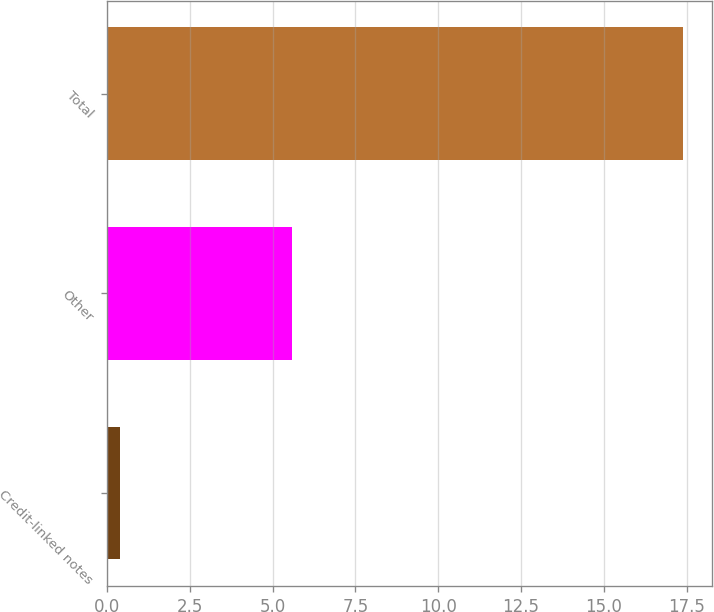Convert chart. <chart><loc_0><loc_0><loc_500><loc_500><bar_chart><fcel>Credit-linked notes<fcel>Other<fcel>Total<nl><fcel>0.4<fcel>5.6<fcel>17.4<nl></chart> 